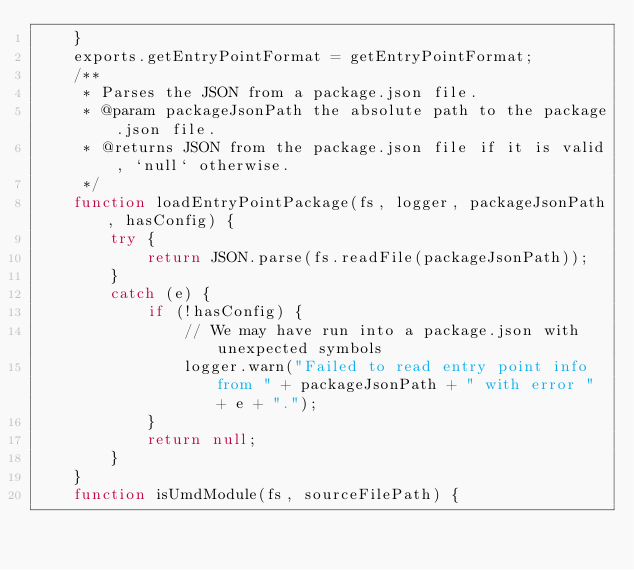Convert code to text. <code><loc_0><loc_0><loc_500><loc_500><_JavaScript_>    }
    exports.getEntryPointFormat = getEntryPointFormat;
    /**
     * Parses the JSON from a package.json file.
     * @param packageJsonPath the absolute path to the package.json file.
     * @returns JSON from the package.json file if it is valid, `null` otherwise.
     */
    function loadEntryPointPackage(fs, logger, packageJsonPath, hasConfig) {
        try {
            return JSON.parse(fs.readFile(packageJsonPath));
        }
        catch (e) {
            if (!hasConfig) {
                // We may have run into a package.json with unexpected symbols
                logger.warn("Failed to read entry point info from " + packageJsonPath + " with error " + e + ".");
            }
            return null;
        }
    }
    function isUmdModule(fs, sourceFilePath) {</code> 